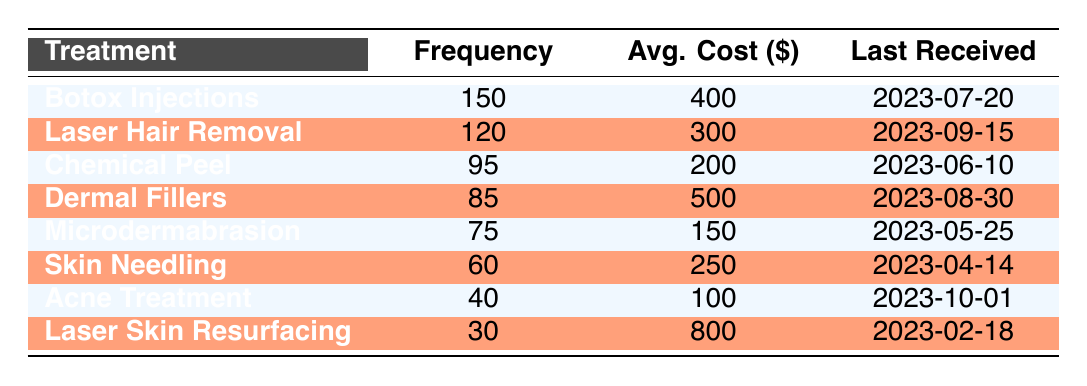What is the average cost of the Botox Injections treatment? The average cost for Botox Injections is given directly in the table as 400.
Answer: 400 Which treatment had the lowest frequency received? Looking at the frequency column, Laser Skin Resurfacing shows the lowest frequency with 30.
Answer: 30 How many treatments had a frequency of 75 or more? By reviewing the frequency column, the treatments with a frequency of 75 or more are Botox Injections (150), Laser Hair Removal (120), Chemical Peel (95), Dermal Fillers (85), and Microdermabrasion (75). This totals to 5 treatments.
Answer: 5 Is the average cost of Chemical Peel higher than the average cost of Skin Needling? The average cost of Chemical Peel is 200 and the average cost of Skin Needling is 250. Since 200 is less than 250, the answer is no.
Answer: No What is the total frequency of all treatments combined? Summing all the frequencies gives: 150 + 120 + 95 + 85 + 75 + 60 + 40 + 30 = 655.
Answer: 655 What treatment had the highest average cost, and what is that cost? The table shows Laser Skin Resurfacing has the highest average cost at 800.
Answer: 800 How many days have passed since the last received treatment for Acne Treatment? The last received date for Acne Treatment is October 1, 2023. If today is October 10, 2023, then 9 days have passed since the treatment.
Answer: 9 Are all treatments below the average cost of Laser Hair Removal? The average cost of Laser Hair Removal is 300. Comparing it with all treatments, Chemical Peel (200), Microdermabrasion (150), Skin Needling (250), and Acne Treatment (100) are below it, but Dermal Fillers (500) and Botox Injections (400) are above it. Thus, the answer is no.
Answer: No Calculate the difference in frequency between the most and least received treatments. The most received treatment is Botox Injections with a frequency of 150, and the least is Laser Skin Resurfacing with 30. The difference is 150 - 30 = 120.
Answer: 120 